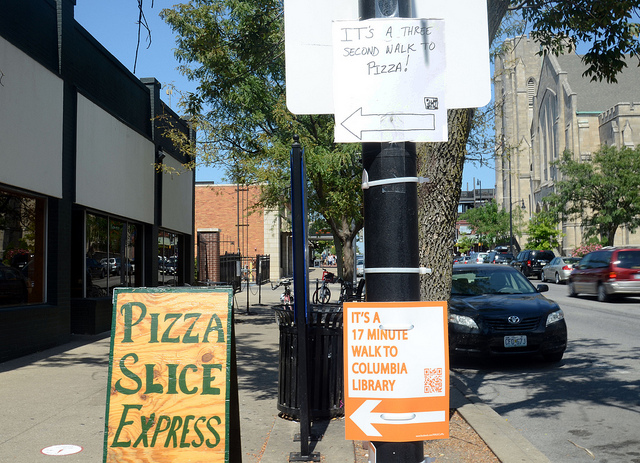What is the building across the street from the orange sign used for? Based on the image, it is not possible to accurately determine the specific use of the building across the street solely from the provided viewpoint and signage. However, the presence of directional signs for a library and an advertisement for pizza suggests a mixed-use area that could include businesses or educational facilities. For a precise identification, further information or a different angle of the building would be required. 